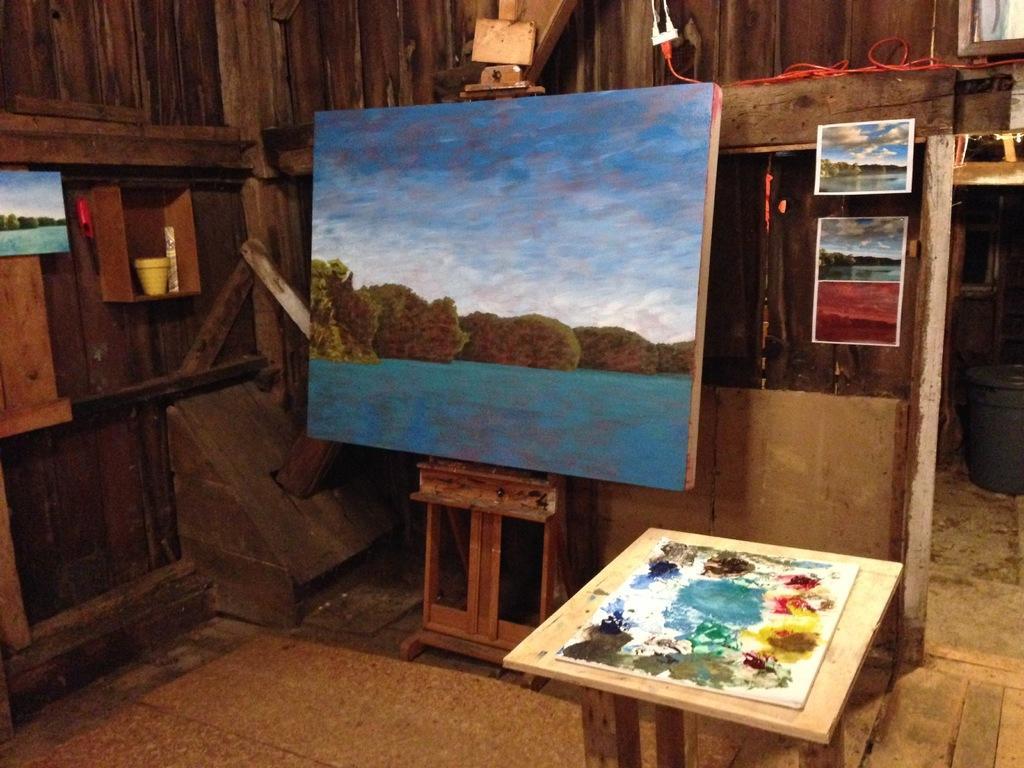Could you give a brief overview of what you see in this image? In the image there is a painting board and also some posters beside it in the background there is a wooden wall and also some Paints. 